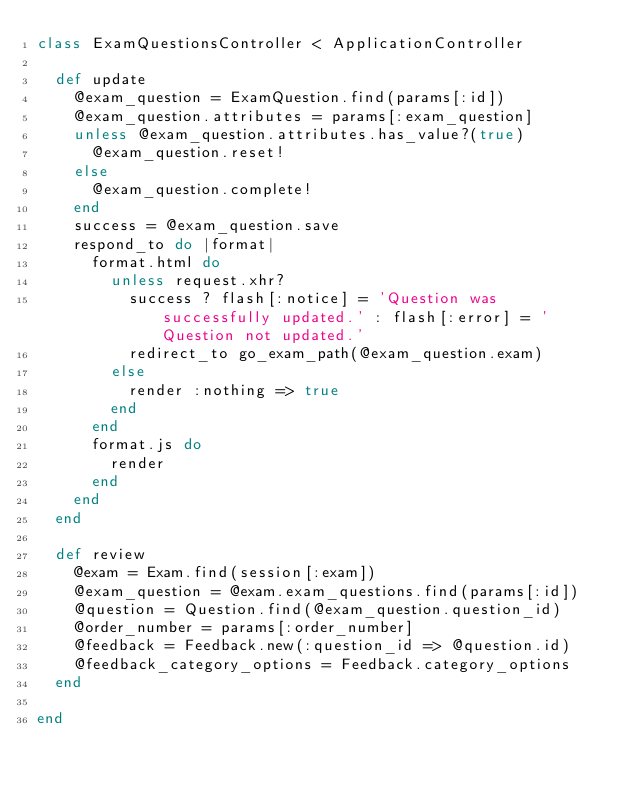<code> <loc_0><loc_0><loc_500><loc_500><_Ruby_>class ExamQuestionsController < ApplicationController

  def update
    @exam_question = ExamQuestion.find(params[:id])
    @exam_question.attributes = params[:exam_question]
    unless @exam_question.attributes.has_value?(true)
      @exam_question.reset!
    else
      @exam_question.complete!
    end
    success = @exam_question.save
    respond_to do |format|
      format.html do
        unless request.xhr?
          success ? flash[:notice] = 'Question was successfully updated.' : flash[:error] = 'Question not updated.'
          redirect_to go_exam_path(@exam_question.exam)
        else
          render :nothing => true
        end
      end
      format.js do
        render
      end
    end
  end

  def review
    @exam = Exam.find(session[:exam])
    @exam_question = @exam.exam_questions.find(params[:id])
    @question = Question.find(@exam_question.question_id)
    @order_number = params[:order_number]
    @feedback = Feedback.new(:question_id => @question.id)
    @feedback_category_options = Feedback.category_options
  end

end

</code> 